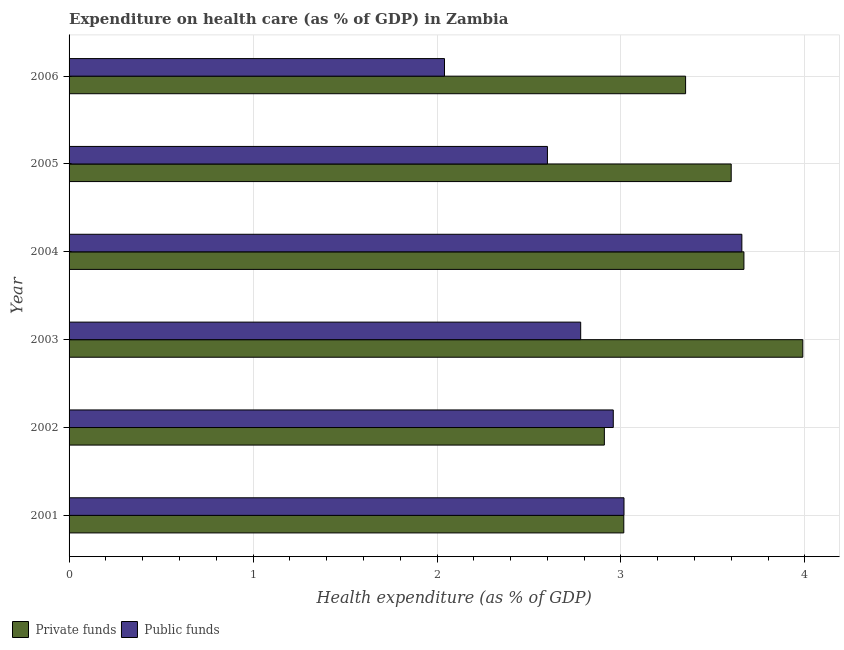How many groups of bars are there?
Give a very brief answer. 6. Are the number of bars on each tick of the Y-axis equal?
Offer a very short reply. Yes. How many bars are there on the 4th tick from the bottom?
Keep it short and to the point. 2. What is the amount of private funds spent in healthcare in 2005?
Your answer should be compact. 3.6. Across all years, what is the maximum amount of public funds spent in healthcare?
Make the answer very short. 3.66. Across all years, what is the minimum amount of private funds spent in healthcare?
Give a very brief answer. 2.91. In which year was the amount of public funds spent in healthcare minimum?
Your response must be concise. 2006. What is the total amount of public funds spent in healthcare in the graph?
Ensure brevity in your answer.  17.05. What is the difference between the amount of private funds spent in healthcare in 2002 and that in 2003?
Your response must be concise. -1.08. What is the difference between the amount of private funds spent in healthcare in 2006 and the amount of public funds spent in healthcare in 2001?
Give a very brief answer. 0.33. What is the average amount of public funds spent in healthcare per year?
Your response must be concise. 2.84. In the year 2004, what is the difference between the amount of private funds spent in healthcare and amount of public funds spent in healthcare?
Offer a very short reply. 0.01. In how many years, is the amount of private funds spent in healthcare greater than 3 %?
Keep it short and to the point. 5. What is the ratio of the amount of public funds spent in healthcare in 2002 to that in 2005?
Keep it short and to the point. 1.14. What is the difference between the highest and the second highest amount of private funds spent in healthcare?
Provide a short and direct response. 0.32. What is the difference between the highest and the lowest amount of public funds spent in healthcare?
Ensure brevity in your answer.  1.62. In how many years, is the amount of public funds spent in healthcare greater than the average amount of public funds spent in healthcare taken over all years?
Your answer should be very brief. 3. What does the 2nd bar from the top in 2001 represents?
Offer a terse response. Private funds. What does the 2nd bar from the bottom in 2002 represents?
Make the answer very short. Public funds. Are all the bars in the graph horizontal?
Your answer should be compact. Yes. What is the difference between two consecutive major ticks on the X-axis?
Your answer should be compact. 1. Does the graph contain any zero values?
Make the answer very short. No. Does the graph contain grids?
Make the answer very short. Yes. Where does the legend appear in the graph?
Your response must be concise. Bottom left. How many legend labels are there?
Offer a very short reply. 2. What is the title of the graph?
Give a very brief answer. Expenditure on health care (as % of GDP) in Zambia. Does "Number of departures" appear as one of the legend labels in the graph?
Offer a very short reply. No. What is the label or title of the X-axis?
Ensure brevity in your answer.  Health expenditure (as % of GDP). What is the label or title of the Y-axis?
Ensure brevity in your answer.  Year. What is the Health expenditure (as % of GDP) in Private funds in 2001?
Offer a very short reply. 3.02. What is the Health expenditure (as % of GDP) of Public funds in 2001?
Ensure brevity in your answer.  3.02. What is the Health expenditure (as % of GDP) in Private funds in 2002?
Make the answer very short. 2.91. What is the Health expenditure (as % of GDP) of Public funds in 2002?
Ensure brevity in your answer.  2.96. What is the Health expenditure (as % of GDP) of Private funds in 2003?
Provide a succinct answer. 3.99. What is the Health expenditure (as % of GDP) of Public funds in 2003?
Give a very brief answer. 2.78. What is the Health expenditure (as % of GDP) of Private funds in 2004?
Offer a very short reply. 3.67. What is the Health expenditure (as % of GDP) of Public funds in 2004?
Provide a short and direct response. 3.66. What is the Health expenditure (as % of GDP) of Private funds in 2005?
Provide a succinct answer. 3.6. What is the Health expenditure (as % of GDP) of Public funds in 2005?
Your response must be concise. 2.6. What is the Health expenditure (as % of GDP) in Private funds in 2006?
Provide a succinct answer. 3.35. What is the Health expenditure (as % of GDP) of Public funds in 2006?
Keep it short and to the point. 2.04. Across all years, what is the maximum Health expenditure (as % of GDP) in Private funds?
Your response must be concise. 3.99. Across all years, what is the maximum Health expenditure (as % of GDP) in Public funds?
Offer a very short reply. 3.66. Across all years, what is the minimum Health expenditure (as % of GDP) in Private funds?
Make the answer very short. 2.91. Across all years, what is the minimum Health expenditure (as % of GDP) of Public funds?
Keep it short and to the point. 2.04. What is the total Health expenditure (as % of GDP) of Private funds in the graph?
Offer a terse response. 20.53. What is the total Health expenditure (as % of GDP) in Public funds in the graph?
Your response must be concise. 17.05. What is the difference between the Health expenditure (as % of GDP) in Private funds in 2001 and that in 2002?
Provide a succinct answer. 0.11. What is the difference between the Health expenditure (as % of GDP) in Public funds in 2001 and that in 2002?
Keep it short and to the point. 0.06. What is the difference between the Health expenditure (as % of GDP) in Private funds in 2001 and that in 2003?
Give a very brief answer. -0.97. What is the difference between the Health expenditure (as % of GDP) of Public funds in 2001 and that in 2003?
Make the answer very short. 0.24. What is the difference between the Health expenditure (as % of GDP) in Private funds in 2001 and that in 2004?
Offer a terse response. -0.65. What is the difference between the Health expenditure (as % of GDP) of Public funds in 2001 and that in 2004?
Give a very brief answer. -0.64. What is the difference between the Health expenditure (as % of GDP) in Private funds in 2001 and that in 2005?
Offer a terse response. -0.58. What is the difference between the Health expenditure (as % of GDP) in Public funds in 2001 and that in 2005?
Your response must be concise. 0.42. What is the difference between the Health expenditure (as % of GDP) in Private funds in 2001 and that in 2006?
Give a very brief answer. -0.34. What is the difference between the Health expenditure (as % of GDP) in Public funds in 2001 and that in 2006?
Give a very brief answer. 0.98. What is the difference between the Health expenditure (as % of GDP) of Private funds in 2002 and that in 2003?
Your answer should be very brief. -1.08. What is the difference between the Health expenditure (as % of GDP) in Public funds in 2002 and that in 2003?
Your answer should be very brief. 0.18. What is the difference between the Health expenditure (as % of GDP) in Private funds in 2002 and that in 2004?
Give a very brief answer. -0.76. What is the difference between the Health expenditure (as % of GDP) in Public funds in 2002 and that in 2004?
Offer a very short reply. -0.7. What is the difference between the Health expenditure (as % of GDP) in Private funds in 2002 and that in 2005?
Your answer should be compact. -0.69. What is the difference between the Health expenditure (as % of GDP) of Public funds in 2002 and that in 2005?
Keep it short and to the point. 0.36. What is the difference between the Health expenditure (as % of GDP) of Private funds in 2002 and that in 2006?
Provide a succinct answer. -0.44. What is the difference between the Health expenditure (as % of GDP) of Public funds in 2002 and that in 2006?
Offer a very short reply. 0.92. What is the difference between the Health expenditure (as % of GDP) of Private funds in 2003 and that in 2004?
Make the answer very short. 0.32. What is the difference between the Health expenditure (as % of GDP) in Public funds in 2003 and that in 2004?
Provide a short and direct response. -0.88. What is the difference between the Health expenditure (as % of GDP) in Private funds in 2003 and that in 2005?
Your answer should be very brief. 0.39. What is the difference between the Health expenditure (as % of GDP) in Public funds in 2003 and that in 2005?
Give a very brief answer. 0.18. What is the difference between the Health expenditure (as % of GDP) in Private funds in 2003 and that in 2006?
Provide a short and direct response. 0.64. What is the difference between the Health expenditure (as % of GDP) of Public funds in 2003 and that in 2006?
Keep it short and to the point. 0.74. What is the difference between the Health expenditure (as % of GDP) in Private funds in 2004 and that in 2005?
Provide a succinct answer. 0.07. What is the difference between the Health expenditure (as % of GDP) in Public funds in 2004 and that in 2005?
Your answer should be compact. 1.06. What is the difference between the Health expenditure (as % of GDP) of Private funds in 2004 and that in 2006?
Your answer should be compact. 0.32. What is the difference between the Health expenditure (as % of GDP) in Public funds in 2004 and that in 2006?
Make the answer very short. 1.62. What is the difference between the Health expenditure (as % of GDP) in Private funds in 2005 and that in 2006?
Give a very brief answer. 0.25. What is the difference between the Health expenditure (as % of GDP) of Public funds in 2005 and that in 2006?
Your answer should be very brief. 0.56. What is the difference between the Health expenditure (as % of GDP) of Private funds in 2001 and the Health expenditure (as % of GDP) of Public funds in 2002?
Provide a succinct answer. 0.06. What is the difference between the Health expenditure (as % of GDP) in Private funds in 2001 and the Health expenditure (as % of GDP) in Public funds in 2003?
Ensure brevity in your answer.  0.23. What is the difference between the Health expenditure (as % of GDP) in Private funds in 2001 and the Health expenditure (as % of GDP) in Public funds in 2004?
Keep it short and to the point. -0.64. What is the difference between the Health expenditure (as % of GDP) in Private funds in 2001 and the Health expenditure (as % of GDP) in Public funds in 2005?
Give a very brief answer. 0.42. What is the difference between the Health expenditure (as % of GDP) of Private funds in 2001 and the Health expenditure (as % of GDP) of Public funds in 2006?
Offer a terse response. 0.97. What is the difference between the Health expenditure (as % of GDP) in Private funds in 2002 and the Health expenditure (as % of GDP) in Public funds in 2003?
Your answer should be compact. 0.13. What is the difference between the Health expenditure (as % of GDP) in Private funds in 2002 and the Health expenditure (as % of GDP) in Public funds in 2004?
Your answer should be compact. -0.75. What is the difference between the Health expenditure (as % of GDP) of Private funds in 2002 and the Health expenditure (as % of GDP) of Public funds in 2005?
Offer a very short reply. 0.31. What is the difference between the Health expenditure (as % of GDP) of Private funds in 2002 and the Health expenditure (as % of GDP) of Public funds in 2006?
Offer a very short reply. 0.87. What is the difference between the Health expenditure (as % of GDP) of Private funds in 2003 and the Health expenditure (as % of GDP) of Public funds in 2004?
Give a very brief answer. 0.33. What is the difference between the Health expenditure (as % of GDP) in Private funds in 2003 and the Health expenditure (as % of GDP) in Public funds in 2005?
Your answer should be very brief. 1.39. What is the difference between the Health expenditure (as % of GDP) in Private funds in 2003 and the Health expenditure (as % of GDP) in Public funds in 2006?
Keep it short and to the point. 1.95. What is the difference between the Health expenditure (as % of GDP) in Private funds in 2004 and the Health expenditure (as % of GDP) in Public funds in 2005?
Offer a very short reply. 1.07. What is the difference between the Health expenditure (as % of GDP) in Private funds in 2004 and the Health expenditure (as % of GDP) in Public funds in 2006?
Your response must be concise. 1.63. What is the difference between the Health expenditure (as % of GDP) of Private funds in 2005 and the Health expenditure (as % of GDP) of Public funds in 2006?
Your answer should be compact. 1.56. What is the average Health expenditure (as % of GDP) of Private funds per year?
Ensure brevity in your answer.  3.42. What is the average Health expenditure (as % of GDP) of Public funds per year?
Keep it short and to the point. 2.84. In the year 2001, what is the difference between the Health expenditure (as % of GDP) in Private funds and Health expenditure (as % of GDP) in Public funds?
Offer a terse response. -0. In the year 2002, what is the difference between the Health expenditure (as % of GDP) of Private funds and Health expenditure (as % of GDP) of Public funds?
Keep it short and to the point. -0.05. In the year 2003, what is the difference between the Health expenditure (as % of GDP) in Private funds and Health expenditure (as % of GDP) in Public funds?
Offer a terse response. 1.21. In the year 2004, what is the difference between the Health expenditure (as % of GDP) in Private funds and Health expenditure (as % of GDP) in Public funds?
Keep it short and to the point. 0.01. In the year 2006, what is the difference between the Health expenditure (as % of GDP) of Private funds and Health expenditure (as % of GDP) of Public funds?
Your response must be concise. 1.31. What is the ratio of the Health expenditure (as % of GDP) in Private funds in 2001 to that in 2002?
Provide a short and direct response. 1.04. What is the ratio of the Health expenditure (as % of GDP) of Public funds in 2001 to that in 2002?
Provide a succinct answer. 1.02. What is the ratio of the Health expenditure (as % of GDP) in Private funds in 2001 to that in 2003?
Provide a short and direct response. 0.76. What is the ratio of the Health expenditure (as % of GDP) in Public funds in 2001 to that in 2003?
Ensure brevity in your answer.  1.08. What is the ratio of the Health expenditure (as % of GDP) in Private funds in 2001 to that in 2004?
Your answer should be compact. 0.82. What is the ratio of the Health expenditure (as % of GDP) in Public funds in 2001 to that in 2004?
Keep it short and to the point. 0.82. What is the ratio of the Health expenditure (as % of GDP) in Private funds in 2001 to that in 2005?
Give a very brief answer. 0.84. What is the ratio of the Health expenditure (as % of GDP) in Public funds in 2001 to that in 2005?
Your answer should be compact. 1.16. What is the ratio of the Health expenditure (as % of GDP) of Private funds in 2001 to that in 2006?
Keep it short and to the point. 0.9. What is the ratio of the Health expenditure (as % of GDP) in Public funds in 2001 to that in 2006?
Keep it short and to the point. 1.48. What is the ratio of the Health expenditure (as % of GDP) of Private funds in 2002 to that in 2003?
Offer a terse response. 0.73. What is the ratio of the Health expenditure (as % of GDP) of Public funds in 2002 to that in 2003?
Provide a short and direct response. 1.06. What is the ratio of the Health expenditure (as % of GDP) in Private funds in 2002 to that in 2004?
Offer a terse response. 0.79. What is the ratio of the Health expenditure (as % of GDP) in Public funds in 2002 to that in 2004?
Offer a terse response. 0.81. What is the ratio of the Health expenditure (as % of GDP) of Private funds in 2002 to that in 2005?
Give a very brief answer. 0.81. What is the ratio of the Health expenditure (as % of GDP) of Public funds in 2002 to that in 2005?
Keep it short and to the point. 1.14. What is the ratio of the Health expenditure (as % of GDP) of Private funds in 2002 to that in 2006?
Ensure brevity in your answer.  0.87. What is the ratio of the Health expenditure (as % of GDP) in Public funds in 2002 to that in 2006?
Ensure brevity in your answer.  1.45. What is the ratio of the Health expenditure (as % of GDP) in Private funds in 2003 to that in 2004?
Keep it short and to the point. 1.09. What is the ratio of the Health expenditure (as % of GDP) of Public funds in 2003 to that in 2004?
Make the answer very short. 0.76. What is the ratio of the Health expenditure (as % of GDP) in Private funds in 2003 to that in 2005?
Provide a short and direct response. 1.11. What is the ratio of the Health expenditure (as % of GDP) in Public funds in 2003 to that in 2005?
Keep it short and to the point. 1.07. What is the ratio of the Health expenditure (as % of GDP) of Private funds in 2003 to that in 2006?
Make the answer very short. 1.19. What is the ratio of the Health expenditure (as % of GDP) in Public funds in 2003 to that in 2006?
Your answer should be very brief. 1.36. What is the ratio of the Health expenditure (as % of GDP) of Private funds in 2004 to that in 2005?
Keep it short and to the point. 1.02. What is the ratio of the Health expenditure (as % of GDP) of Public funds in 2004 to that in 2005?
Offer a very short reply. 1.41. What is the ratio of the Health expenditure (as % of GDP) in Private funds in 2004 to that in 2006?
Provide a succinct answer. 1.09. What is the ratio of the Health expenditure (as % of GDP) in Public funds in 2004 to that in 2006?
Your answer should be compact. 1.79. What is the ratio of the Health expenditure (as % of GDP) of Private funds in 2005 to that in 2006?
Offer a very short reply. 1.07. What is the ratio of the Health expenditure (as % of GDP) of Public funds in 2005 to that in 2006?
Give a very brief answer. 1.27. What is the difference between the highest and the second highest Health expenditure (as % of GDP) in Private funds?
Keep it short and to the point. 0.32. What is the difference between the highest and the second highest Health expenditure (as % of GDP) of Public funds?
Offer a terse response. 0.64. What is the difference between the highest and the lowest Health expenditure (as % of GDP) in Private funds?
Ensure brevity in your answer.  1.08. What is the difference between the highest and the lowest Health expenditure (as % of GDP) of Public funds?
Provide a short and direct response. 1.62. 